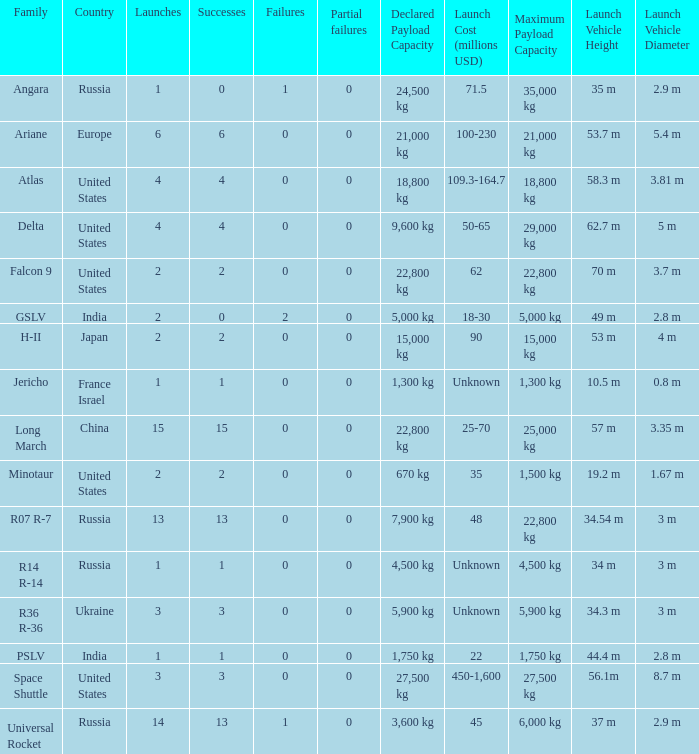What is the partial failure for the Country of russia, and a Failure larger than 0, and a Family of angara, and a Launch larger than 1? None. 